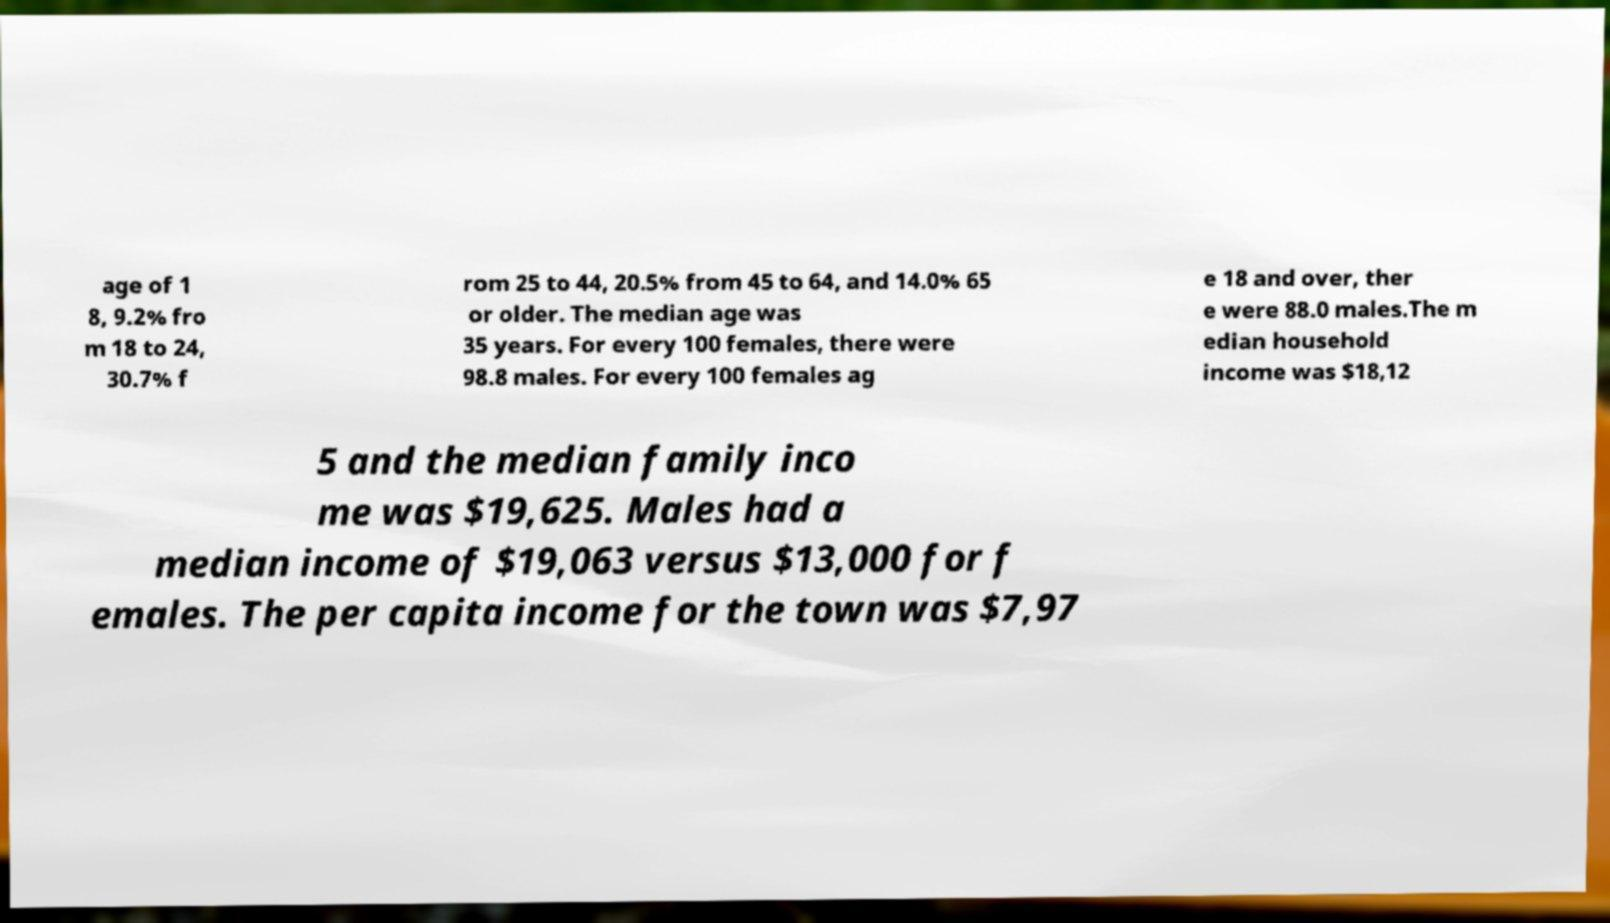Could you assist in decoding the text presented in this image and type it out clearly? age of 1 8, 9.2% fro m 18 to 24, 30.7% f rom 25 to 44, 20.5% from 45 to 64, and 14.0% 65 or older. The median age was 35 years. For every 100 females, there were 98.8 males. For every 100 females ag e 18 and over, ther e were 88.0 males.The m edian household income was $18,12 5 and the median family inco me was $19,625. Males had a median income of $19,063 versus $13,000 for f emales. The per capita income for the town was $7,97 